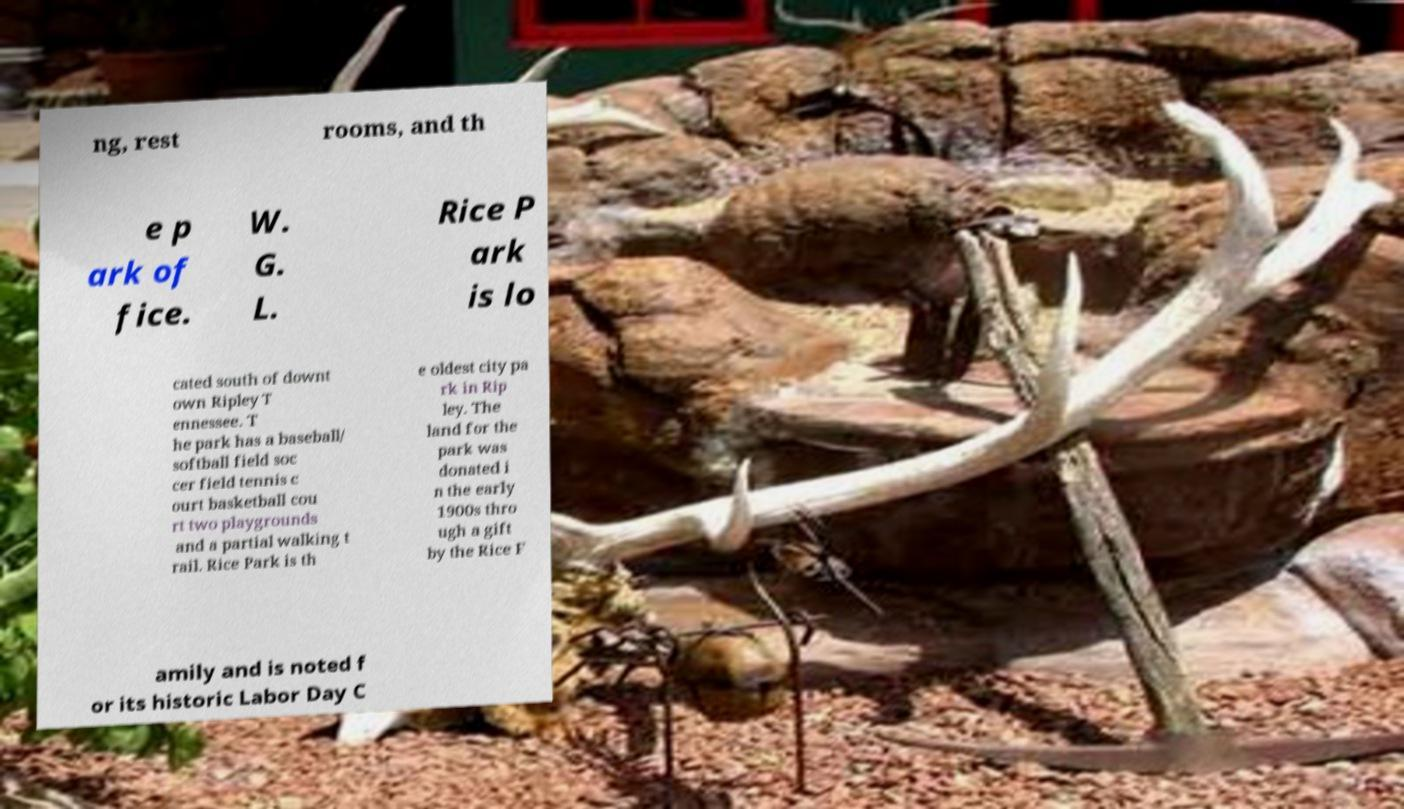Can you read and provide the text displayed in the image?This photo seems to have some interesting text. Can you extract and type it out for me? ng, rest rooms, and th e p ark of fice. W. G. L. Rice P ark is lo cated south of downt own Ripley T ennessee. T he park has a baseball/ softball field soc cer field tennis c ourt basketball cou rt two playgrounds and a partial walking t rail. Rice Park is th e oldest city pa rk in Rip ley. The land for the park was donated i n the early 1900s thro ugh a gift by the Rice F amily and is noted f or its historic Labor Day C 